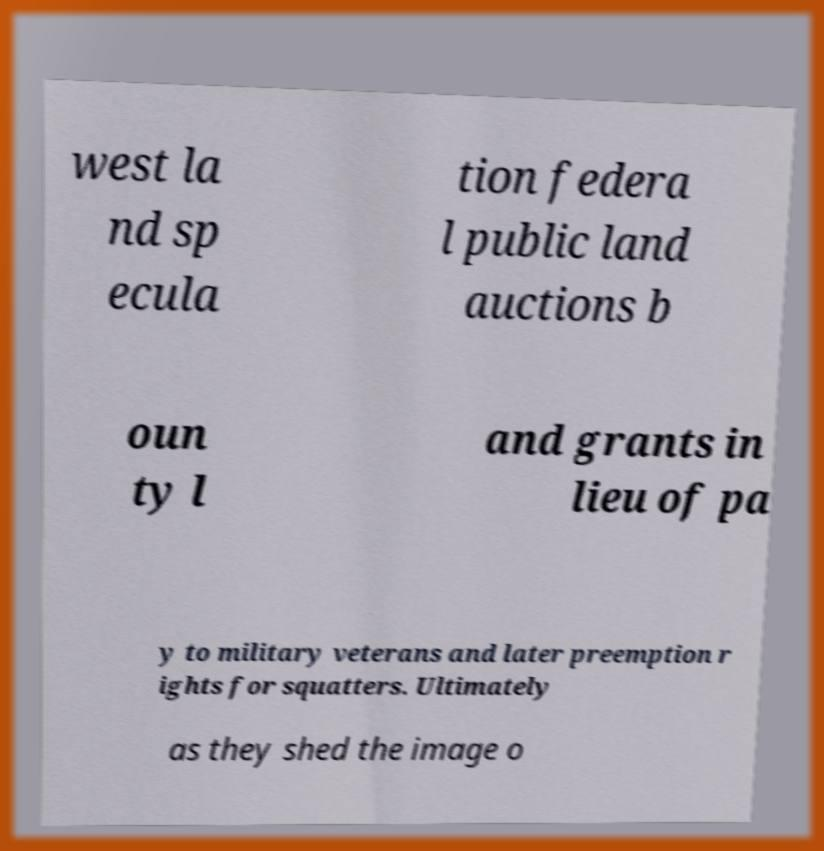Please read and relay the text visible in this image. What does it say? west la nd sp ecula tion federa l public land auctions b oun ty l and grants in lieu of pa y to military veterans and later preemption r ights for squatters. Ultimately as they shed the image o 